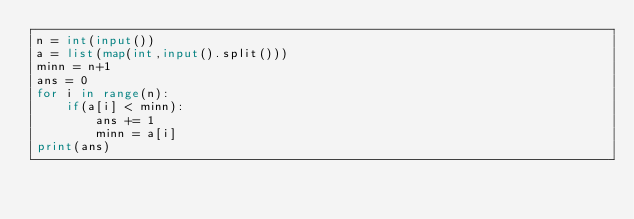Convert code to text. <code><loc_0><loc_0><loc_500><loc_500><_Python_>n = int(input())
a = list(map(int,input().split()))
minn = n+1
ans = 0
for i in range(n):
	if(a[i] < minn):
		ans += 1
		minn = a[i]
print(ans)
</code> 